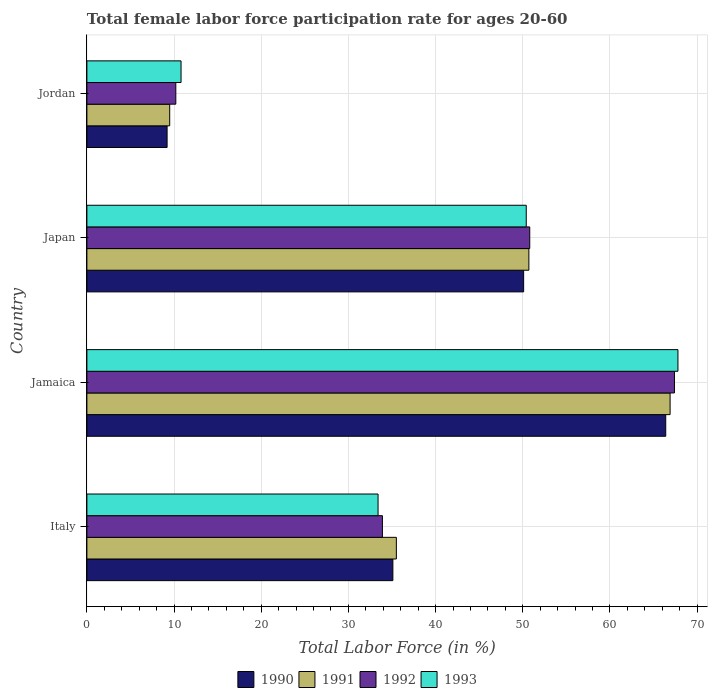How many different coloured bars are there?
Your answer should be compact. 4. How many groups of bars are there?
Offer a very short reply. 4. Are the number of bars per tick equal to the number of legend labels?
Ensure brevity in your answer.  Yes. Are the number of bars on each tick of the Y-axis equal?
Provide a succinct answer. Yes. How many bars are there on the 4th tick from the bottom?
Provide a succinct answer. 4. What is the label of the 2nd group of bars from the top?
Offer a very short reply. Japan. In how many cases, is the number of bars for a given country not equal to the number of legend labels?
Offer a terse response. 0. What is the female labor force participation rate in 1993 in Japan?
Your answer should be very brief. 50.4. Across all countries, what is the maximum female labor force participation rate in 1990?
Provide a short and direct response. 66.4. In which country was the female labor force participation rate in 1990 maximum?
Your answer should be very brief. Jamaica. In which country was the female labor force participation rate in 1991 minimum?
Ensure brevity in your answer.  Jordan. What is the total female labor force participation rate in 1991 in the graph?
Your answer should be compact. 162.6. What is the difference between the female labor force participation rate in 1990 in Italy and that in Jordan?
Ensure brevity in your answer.  25.9. What is the difference between the female labor force participation rate in 1993 in Jordan and the female labor force participation rate in 1991 in Italy?
Provide a succinct answer. -24.7. What is the average female labor force participation rate in 1990 per country?
Your response must be concise. 40.2. What is the difference between the female labor force participation rate in 1993 and female labor force participation rate in 1990 in Jamaica?
Your answer should be compact. 1.4. In how many countries, is the female labor force participation rate in 1990 greater than 56 %?
Give a very brief answer. 1. What is the ratio of the female labor force participation rate in 1990 in Jamaica to that in Japan?
Ensure brevity in your answer.  1.33. Is the female labor force participation rate in 1991 in Japan less than that in Jordan?
Provide a succinct answer. No. Is the difference between the female labor force participation rate in 1993 in Jamaica and Japan greater than the difference between the female labor force participation rate in 1990 in Jamaica and Japan?
Ensure brevity in your answer.  Yes. What is the difference between the highest and the second highest female labor force participation rate in 1990?
Your answer should be compact. 16.3. What is the difference between the highest and the lowest female labor force participation rate in 1990?
Make the answer very short. 57.2. Is the sum of the female labor force participation rate in 1992 in Italy and Jordan greater than the maximum female labor force participation rate in 1990 across all countries?
Provide a short and direct response. No. Is it the case that in every country, the sum of the female labor force participation rate in 1991 and female labor force participation rate in 1992 is greater than the sum of female labor force participation rate in 1993 and female labor force participation rate in 1990?
Offer a terse response. No. Is it the case that in every country, the sum of the female labor force participation rate in 1993 and female labor force participation rate in 1991 is greater than the female labor force participation rate in 1990?
Make the answer very short. Yes. How many bars are there?
Your response must be concise. 16. Are all the bars in the graph horizontal?
Keep it short and to the point. Yes. How many countries are there in the graph?
Provide a short and direct response. 4. Does the graph contain any zero values?
Offer a very short reply. No. Does the graph contain grids?
Ensure brevity in your answer.  Yes. How many legend labels are there?
Keep it short and to the point. 4. How are the legend labels stacked?
Give a very brief answer. Horizontal. What is the title of the graph?
Give a very brief answer. Total female labor force participation rate for ages 20-60. What is the label or title of the Y-axis?
Make the answer very short. Country. What is the Total Labor Force (in %) of 1990 in Italy?
Your answer should be compact. 35.1. What is the Total Labor Force (in %) in 1991 in Italy?
Keep it short and to the point. 35.5. What is the Total Labor Force (in %) in 1992 in Italy?
Offer a terse response. 33.9. What is the Total Labor Force (in %) in 1993 in Italy?
Provide a succinct answer. 33.4. What is the Total Labor Force (in %) in 1990 in Jamaica?
Your answer should be very brief. 66.4. What is the Total Labor Force (in %) of 1991 in Jamaica?
Provide a succinct answer. 66.9. What is the Total Labor Force (in %) of 1992 in Jamaica?
Offer a terse response. 67.4. What is the Total Labor Force (in %) in 1993 in Jamaica?
Offer a terse response. 67.8. What is the Total Labor Force (in %) of 1990 in Japan?
Offer a terse response. 50.1. What is the Total Labor Force (in %) in 1991 in Japan?
Provide a short and direct response. 50.7. What is the Total Labor Force (in %) in 1992 in Japan?
Keep it short and to the point. 50.8. What is the Total Labor Force (in %) in 1993 in Japan?
Keep it short and to the point. 50.4. What is the Total Labor Force (in %) in 1990 in Jordan?
Keep it short and to the point. 9.2. What is the Total Labor Force (in %) in 1991 in Jordan?
Provide a short and direct response. 9.5. What is the Total Labor Force (in %) of 1992 in Jordan?
Ensure brevity in your answer.  10.2. What is the Total Labor Force (in %) of 1993 in Jordan?
Ensure brevity in your answer.  10.8. Across all countries, what is the maximum Total Labor Force (in %) in 1990?
Make the answer very short. 66.4. Across all countries, what is the maximum Total Labor Force (in %) of 1991?
Your response must be concise. 66.9. Across all countries, what is the maximum Total Labor Force (in %) of 1992?
Offer a very short reply. 67.4. Across all countries, what is the maximum Total Labor Force (in %) of 1993?
Your answer should be compact. 67.8. Across all countries, what is the minimum Total Labor Force (in %) in 1990?
Provide a succinct answer. 9.2. Across all countries, what is the minimum Total Labor Force (in %) in 1992?
Ensure brevity in your answer.  10.2. Across all countries, what is the minimum Total Labor Force (in %) in 1993?
Provide a succinct answer. 10.8. What is the total Total Labor Force (in %) in 1990 in the graph?
Make the answer very short. 160.8. What is the total Total Labor Force (in %) of 1991 in the graph?
Your response must be concise. 162.6. What is the total Total Labor Force (in %) in 1992 in the graph?
Keep it short and to the point. 162.3. What is the total Total Labor Force (in %) in 1993 in the graph?
Offer a terse response. 162.4. What is the difference between the Total Labor Force (in %) of 1990 in Italy and that in Jamaica?
Provide a succinct answer. -31.3. What is the difference between the Total Labor Force (in %) of 1991 in Italy and that in Jamaica?
Your response must be concise. -31.4. What is the difference between the Total Labor Force (in %) in 1992 in Italy and that in Jamaica?
Keep it short and to the point. -33.5. What is the difference between the Total Labor Force (in %) of 1993 in Italy and that in Jamaica?
Make the answer very short. -34.4. What is the difference between the Total Labor Force (in %) of 1991 in Italy and that in Japan?
Offer a very short reply. -15.2. What is the difference between the Total Labor Force (in %) in 1992 in Italy and that in Japan?
Offer a terse response. -16.9. What is the difference between the Total Labor Force (in %) of 1993 in Italy and that in Japan?
Your answer should be very brief. -17. What is the difference between the Total Labor Force (in %) in 1990 in Italy and that in Jordan?
Give a very brief answer. 25.9. What is the difference between the Total Labor Force (in %) in 1992 in Italy and that in Jordan?
Your answer should be very brief. 23.7. What is the difference between the Total Labor Force (in %) of 1993 in Italy and that in Jordan?
Keep it short and to the point. 22.6. What is the difference between the Total Labor Force (in %) in 1991 in Jamaica and that in Japan?
Provide a succinct answer. 16.2. What is the difference between the Total Labor Force (in %) in 1993 in Jamaica and that in Japan?
Your answer should be compact. 17.4. What is the difference between the Total Labor Force (in %) of 1990 in Jamaica and that in Jordan?
Keep it short and to the point. 57.2. What is the difference between the Total Labor Force (in %) in 1991 in Jamaica and that in Jordan?
Keep it short and to the point. 57.4. What is the difference between the Total Labor Force (in %) in 1992 in Jamaica and that in Jordan?
Offer a terse response. 57.2. What is the difference between the Total Labor Force (in %) in 1993 in Jamaica and that in Jordan?
Ensure brevity in your answer.  57. What is the difference between the Total Labor Force (in %) of 1990 in Japan and that in Jordan?
Make the answer very short. 40.9. What is the difference between the Total Labor Force (in %) in 1991 in Japan and that in Jordan?
Make the answer very short. 41.2. What is the difference between the Total Labor Force (in %) in 1992 in Japan and that in Jordan?
Make the answer very short. 40.6. What is the difference between the Total Labor Force (in %) of 1993 in Japan and that in Jordan?
Your response must be concise. 39.6. What is the difference between the Total Labor Force (in %) of 1990 in Italy and the Total Labor Force (in %) of 1991 in Jamaica?
Offer a very short reply. -31.8. What is the difference between the Total Labor Force (in %) in 1990 in Italy and the Total Labor Force (in %) in 1992 in Jamaica?
Your answer should be compact. -32.3. What is the difference between the Total Labor Force (in %) in 1990 in Italy and the Total Labor Force (in %) in 1993 in Jamaica?
Give a very brief answer. -32.7. What is the difference between the Total Labor Force (in %) in 1991 in Italy and the Total Labor Force (in %) in 1992 in Jamaica?
Your answer should be very brief. -31.9. What is the difference between the Total Labor Force (in %) of 1991 in Italy and the Total Labor Force (in %) of 1993 in Jamaica?
Provide a short and direct response. -32.3. What is the difference between the Total Labor Force (in %) of 1992 in Italy and the Total Labor Force (in %) of 1993 in Jamaica?
Give a very brief answer. -33.9. What is the difference between the Total Labor Force (in %) of 1990 in Italy and the Total Labor Force (in %) of 1991 in Japan?
Your answer should be very brief. -15.6. What is the difference between the Total Labor Force (in %) in 1990 in Italy and the Total Labor Force (in %) in 1992 in Japan?
Provide a short and direct response. -15.7. What is the difference between the Total Labor Force (in %) of 1990 in Italy and the Total Labor Force (in %) of 1993 in Japan?
Keep it short and to the point. -15.3. What is the difference between the Total Labor Force (in %) of 1991 in Italy and the Total Labor Force (in %) of 1992 in Japan?
Ensure brevity in your answer.  -15.3. What is the difference between the Total Labor Force (in %) of 1991 in Italy and the Total Labor Force (in %) of 1993 in Japan?
Provide a short and direct response. -14.9. What is the difference between the Total Labor Force (in %) in 1992 in Italy and the Total Labor Force (in %) in 1993 in Japan?
Your response must be concise. -16.5. What is the difference between the Total Labor Force (in %) of 1990 in Italy and the Total Labor Force (in %) of 1991 in Jordan?
Offer a terse response. 25.6. What is the difference between the Total Labor Force (in %) of 1990 in Italy and the Total Labor Force (in %) of 1992 in Jordan?
Offer a very short reply. 24.9. What is the difference between the Total Labor Force (in %) in 1990 in Italy and the Total Labor Force (in %) in 1993 in Jordan?
Keep it short and to the point. 24.3. What is the difference between the Total Labor Force (in %) in 1991 in Italy and the Total Labor Force (in %) in 1992 in Jordan?
Offer a very short reply. 25.3. What is the difference between the Total Labor Force (in %) in 1991 in Italy and the Total Labor Force (in %) in 1993 in Jordan?
Provide a short and direct response. 24.7. What is the difference between the Total Labor Force (in %) of 1992 in Italy and the Total Labor Force (in %) of 1993 in Jordan?
Ensure brevity in your answer.  23.1. What is the difference between the Total Labor Force (in %) in 1990 in Jamaica and the Total Labor Force (in %) in 1992 in Japan?
Keep it short and to the point. 15.6. What is the difference between the Total Labor Force (in %) in 1990 in Jamaica and the Total Labor Force (in %) in 1993 in Japan?
Offer a terse response. 16. What is the difference between the Total Labor Force (in %) in 1991 in Jamaica and the Total Labor Force (in %) in 1992 in Japan?
Make the answer very short. 16.1. What is the difference between the Total Labor Force (in %) of 1992 in Jamaica and the Total Labor Force (in %) of 1993 in Japan?
Give a very brief answer. 17. What is the difference between the Total Labor Force (in %) in 1990 in Jamaica and the Total Labor Force (in %) in 1991 in Jordan?
Your answer should be very brief. 56.9. What is the difference between the Total Labor Force (in %) of 1990 in Jamaica and the Total Labor Force (in %) of 1992 in Jordan?
Your response must be concise. 56.2. What is the difference between the Total Labor Force (in %) in 1990 in Jamaica and the Total Labor Force (in %) in 1993 in Jordan?
Your answer should be compact. 55.6. What is the difference between the Total Labor Force (in %) of 1991 in Jamaica and the Total Labor Force (in %) of 1992 in Jordan?
Your answer should be very brief. 56.7. What is the difference between the Total Labor Force (in %) of 1991 in Jamaica and the Total Labor Force (in %) of 1993 in Jordan?
Your answer should be very brief. 56.1. What is the difference between the Total Labor Force (in %) of 1992 in Jamaica and the Total Labor Force (in %) of 1993 in Jordan?
Give a very brief answer. 56.6. What is the difference between the Total Labor Force (in %) of 1990 in Japan and the Total Labor Force (in %) of 1991 in Jordan?
Offer a terse response. 40.6. What is the difference between the Total Labor Force (in %) of 1990 in Japan and the Total Labor Force (in %) of 1992 in Jordan?
Keep it short and to the point. 39.9. What is the difference between the Total Labor Force (in %) in 1990 in Japan and the Total Labor Force (in %) in 1993 in Jordan?
Provide a short and direct response. 39.3. What is the difference between the Total Labor Force (in %) of 1991 in Japan and the Total Labor Force (in %) of 1992 in Jordan?
Your answer should be very brief. 40.5. What is the difference between the Total Labor Force (in %) of 1991 in Japan and the Total Labor Force (in %) of 1993 in Jordan?
Provide a succinct answer. 39.9. What is the difference between the Total Labor Force (in %) in 1992 in Japan and the Total Labor Force (in %) in 1993 in Jordan?
Provide a short and direct response. 40. What is the average Total Labor Force (in %) in 1990 per country?
Provide a short and direct response. 40.2. What is the average Total Labor Force (in %) of 1991 per country?
Provide a short and direct response. 40.65. What is the average Total Labor Force (in %) in 1992 per country?
Keep it short and to the point. 40.58. What is the average Total Labor Force (in %) of 1993 per country?
Provide a short and direct response. 40.6. What is the difference between the Total Labor Force (in %) of 1991 and Total Labor Force (in %) of 1992 in Italy?
Offer a very short reply. 1.6. What is the difference between the Total Labor Force (in %) in 1991 and Total Labor Force (in %) in 1993 in Italy?
Offer a terse response. 2.1. What is the difference between the Total Labor Force (in %) in 1990 and Total Labor Force (in %) in 1991 in Jamaica?
Ensure brevity in your answer.  -0.5. What is the difference between the Total Labor Force (in %) in 1991 and Total Labor Force (in %) in 1992 in Jamaica?
Your answer should be compact. -0.5. What is the difference between the Total Labor Force (in %) in 1990 and Total Labor Force (in %) in 1991 in Japan?
Your answer should be very brief. -0.6. What is the difference between the Total Labor Force (in %) in 1990 and Total Labor Force (in %) in 1993 in Japan?
Give a very brief answer. -0.3. What is the difference between the Total Labor Force (in %) of 1991 and Total Labor Force (in %) of 1993 in Japan?
Offer a very short reply. 0.3. What is the difference between the Total Labor Force (in %) in 1992 and Total Labor Force (in %) in 1993 in Japan?
Your answer should be very brief. 0.4. What is the difference between the Total Labor Force (in %) in 1990 and Total Labor Force (in %) in 1991 in Jordan?
Ensure brevity in your answer.  -0.3. What is the difference between the Total Labor Force (in %) of 1990 and Total Labor Force (in %) of 1993 in Jordan?
Provide a succinct answer. -1.6. What is the difference between the Total Labor Force (in %) in 1991 and Total Labor Force (in %) in 1992 in Jordan?
Your answer should be compact. -0.7. What is the ratio of the Total Labor Force (in %) of 1990 in Italy to that in Jamaica?
Give a very brief answer. 0.53. What is the ratio of the Total Labor Force (in %) of 1991 in Italy to that in Jamaica?
Ensure brevity in your answer.  0.53. What is the ratio of the Total Labor Force (in %) of 1992 in Italy to that in Jamaica?
Provide a short and direct response. 0.5. What is the ratio of the Total Labor Force (in %) of 1993 in Italy to that in Jamaica?
Ensure brevity in your answer.  0.49. What is the ratio of the Total Labor Force (in %) of 1990 in Italy to that in Japan?
Make the answer very short. 0.7. What is the ratio of the Total Labor Force (in %) of 1991 in Italy to that in Japan?
Offer a very short reply. 0.7. What is the ratio of the Total Labor Force (in %) in 1992 in Italy to that in Japan?
Your response must be concise. 0.67. What is the ratio of the Total Labor Force (in %) of 1993 in Italy to that in Japan?
Your response must be concise. 0.66. What is the ratio of the Total Labor Force (in %) of 1990 in Italy to that in Jordan?
Make the answer very short. 3.82. What is the ratio of the Total Labor Force (in %) in 1991 in Italy to that in Jordan?
Offer a terse response. 3.74. What is the ratio of the Total Labor Force (in %) in 1992 in Italy to that in Jordan?
Your answer should be compact. 3.32. What is the ratio of the Total Labor Force (in %) in 1993 in Italy to that in Jordan?
Your answer should be compact. 3.09. What is the ratio of the Total Labor Force (in %) of 1990 in Jamaica to that in Japan?
Provide a succinct answer. 1.33. What is the ratio of the Total Labor Force (in %) of 1991 in Jamaica to that in Japan?
Your answer should be compact. 1.32. What is the ratio of the Total Labor Force (in %) in 1992 in Jamaica to that in Japan?
Ensure brevity in your answer.  1.33. What is the ratio of the Total Labor Force (in %) of 1993 in Jamaica to that in Japan?
Give a very brief answer. 1.35. What is the ratio of the Total Labor Force (in %) of 1990 in Jamaica to that in Jordan?
Your answer should be very brief. 7.22. What is the ratio of the Total Labor Force (in %) in 1991 in Jamaica to that in Jordan?
Your response must be concise. 7.04. What is the ratio of the Total Labor Force (in %) in 1992 in Jamaica to that in Jordan?
Offer a very short reply. 6.61. What is the ratio of the Total Labor Force (in %) in 1993 in Jamaica to that in Jordan?
Provide a short and direct response. 6.28. What is the ratio of the Total Labor Force (in %) in 1990 in Japan to that in Jordan?
Provide a succinct answer. 5.45. What is the ratio of the Total Labor Force (in %) of 1991 in Japan to that in Jordan?
Provide a succinct answer. 5.34. What is the ratio of the Total Labor Force (in %) of 1992 in Japan to that in Jordan?
Make the answer very short. 4.98. What is the ratio of the Total Labor Force (in %) of 1993 in Japan to that in Jordan?
Make the answer very short. 4.67. What is the difference between the highest and the second highest Total Labor Force (in %) in 1990?
Offer a terse response. 16.3. What is the difference between the highest and the second highest Total Labor Force (in %) of 1993?
Keep it short and to the point. 17.4. What is the difference between the highest and the lowest Total Labor Force (in %) in 1990?
Ensure brevity in your answer.  57.2. What is the difference between the highest and the lowest Total Labor Force (in %) of 1991?
Make the answer very short. 57.4. What is the difference between the highest and the lowest Total Labor Force (in %) in 1992?
Make the answer very short. 57.2. What is the difference between the highest and the lowest Total Labor Force (in %) of 1993?
Offer a terse response. 57. 